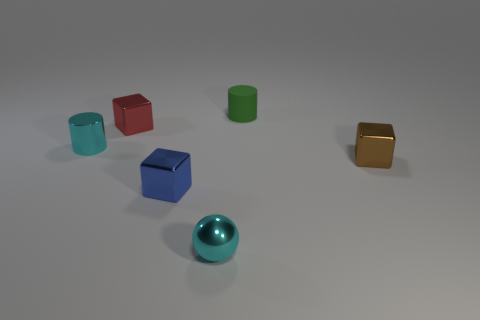There is a shiny thing that is behind the brown thing and on the right side of the cyan cylinder; what is its color?
Ensure brevity in your answer.  Red. How many small objects are brown objects or shiny blocks?
Keep it short and to the point. 3. There is a brown shiny thing that is the same shape as the tiny blue thing; what is its size?
Provide a short and direct response. Small. What is the shape of the brown object?
Offer a terse response. Cube. Do the red object and the tiny block in front of the brown metal thing have the same material?
Ensure brevity in your answer.  Yes. How many matte objects are either small cyan balls or large brown things?
Give a very brief answer. 0. What is the size of the cylinder that is to the left of the rubber cylinder?
Make the answer very short. Small. There is a red object that is the same material as the small blue cube; what is its size?
Ensure brevity in your answer.  Small. What number of blocks are the same color as the matte object?
Make the answer very short. 0. Is there a tiny red metal object?
Provide a short and direct response. Yes. 